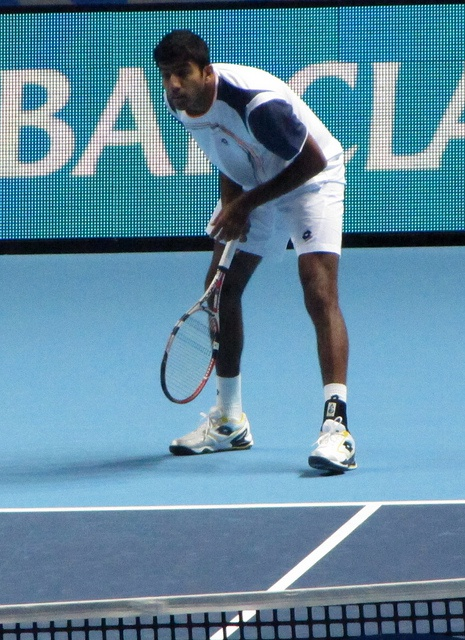Describe the objects in this image and their specific colors. I can see people in navy, black, white, and gray tones and tennis racket in navy, darkgray, lightblue, and gray tones in this image. 